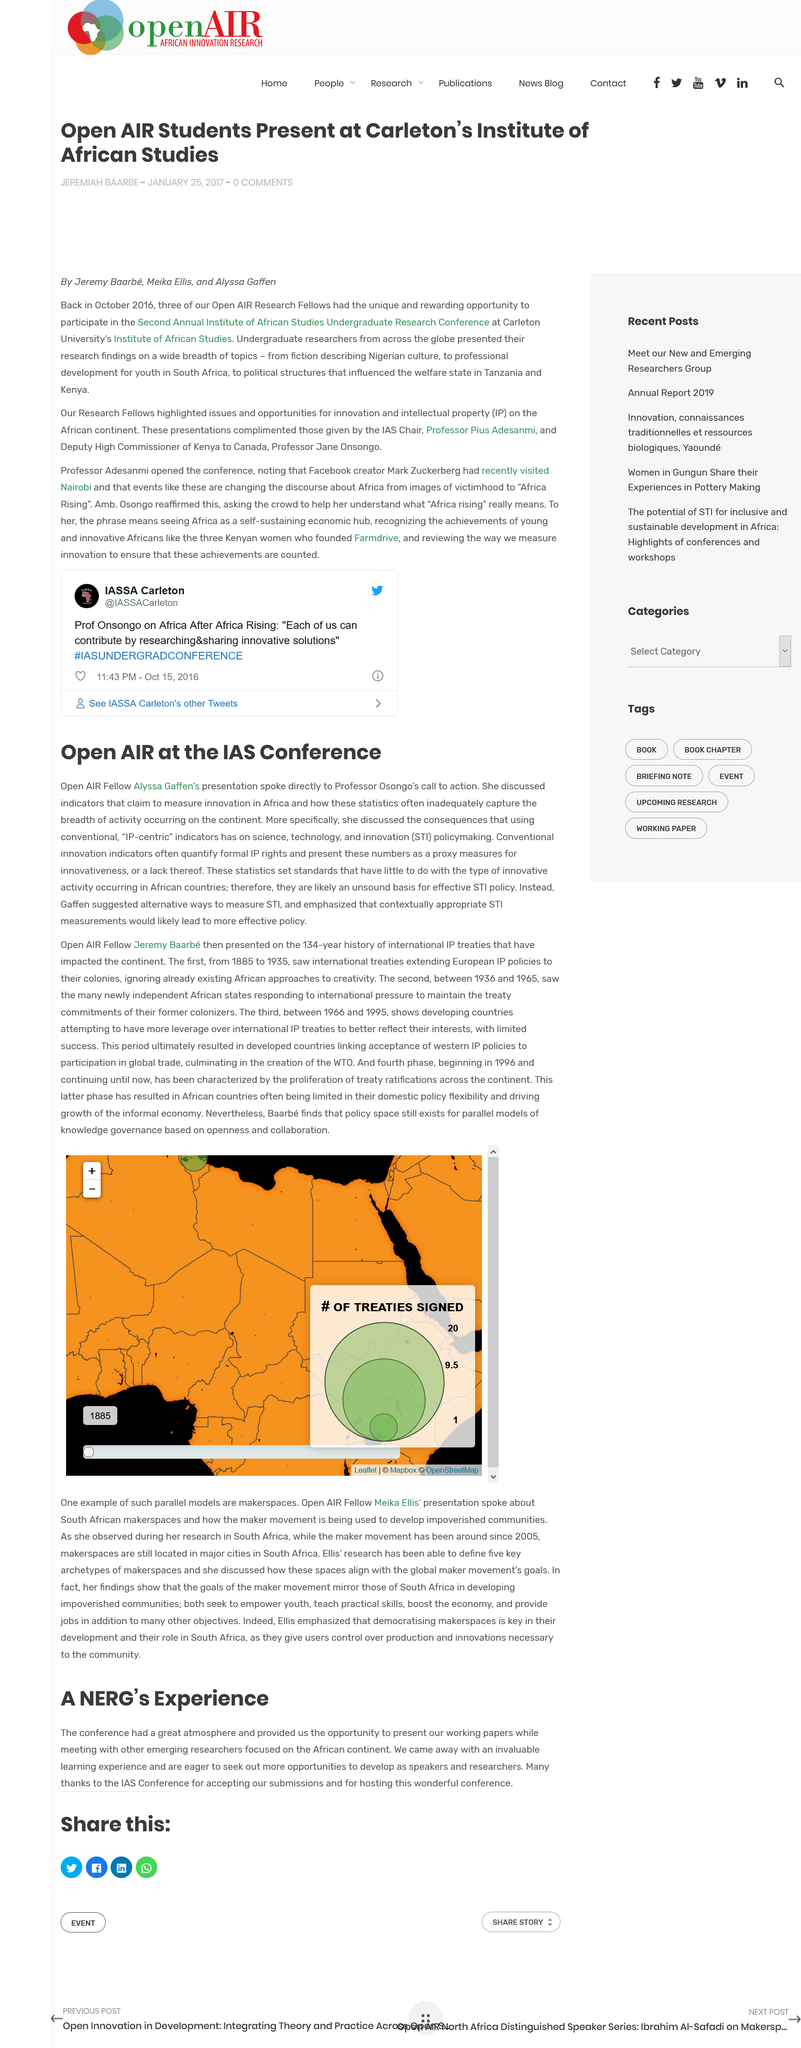Highlight a few significant elements in this photo. Open AIR fellow Alyssa Gaffen spoke at the IAS Conference. There were zero comments made on the article. The article was published on January 25, 2027. Three Open AIR Research Fellows participated in the Second Annual Institute of African Studies Undergraduate Research Conference in October 2016. Alyssa Gaffen's presentation directly addressed Professor Osongo's call to action. 